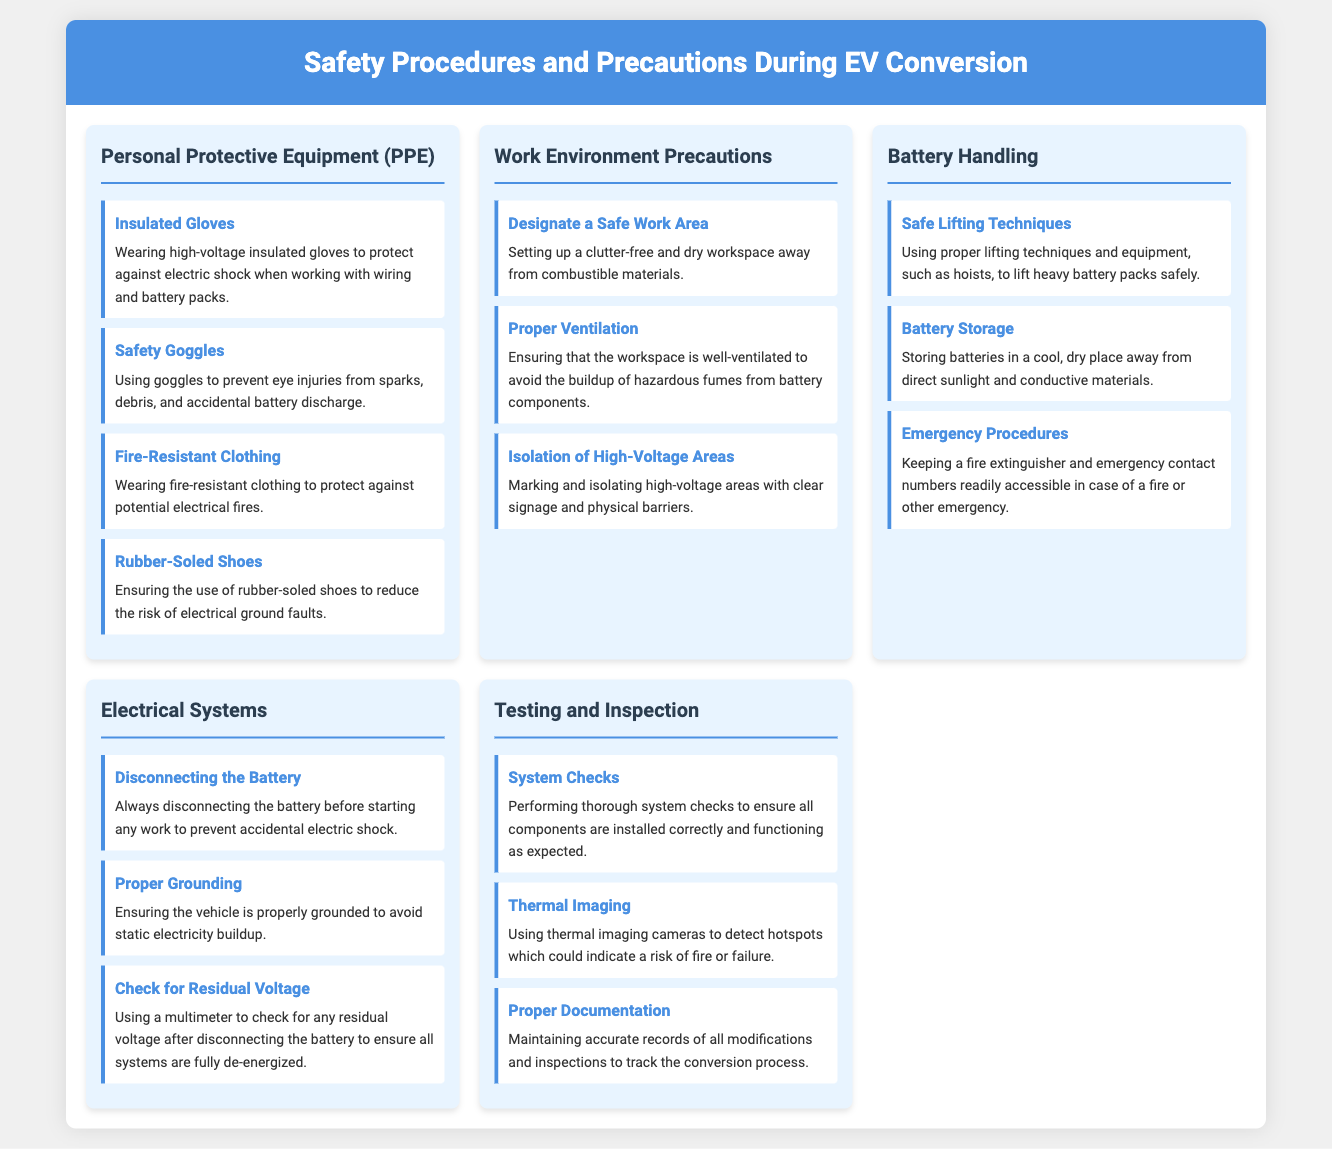What is one piece of Personal Protective Equipment recommended for EV conversion? The document lists several Personal Protective Equipment items, including insulated gloves.
Answer: Insulated Gloves What should be used to prevent eye injuries during the conversion? The section on Personal Protective Equipment specifies the use of safety goggles to prevent eye injuries.
Answer: Safety Goggles What is a key precaution for the work environment during EV conversion? The document mentions designating a safe work area as a precaution in the work environment section.
Answer: Designate a Safe Work Area What kind of clothing is advised to protect against electrical fires? According to the document, fire-resistant clothing should be worn to protect against potential electrical fires.
Answer: Fire-Resistant Clothing How should batteries be stored during the conversion? The document specifies that batteries should be stored in a cool, dry place away from direct sunlight and conductive materials.
Answer: Cool, dry place What is one method mentioned for ensuring safety before beginning work on electric systems? The document highlights the importance of disconnecting the battery before starting any work.
Answer: Disconnecting the Battery What tool is recommended to check for residual voltage after disconnecting the battery? The document states that a multimeter should be used to check for any residual voltage.
Answer: Multimeter What should be performed to ensure all components are functioning correctly? Performing thorough system checks is recommended to ensure all components are installed correctly and functioning as expected.
Answer: System Checks What should be used to detect hotspots during testing? The document mentions using thermal imaging cameras to detect hotspots.
Answer: Thermal Imaging What type of records should be maintained throughout the conversion process? The document emphasizes the importance of maintaining accurate records of all modifications and inspections.
Answer: Accurate records 